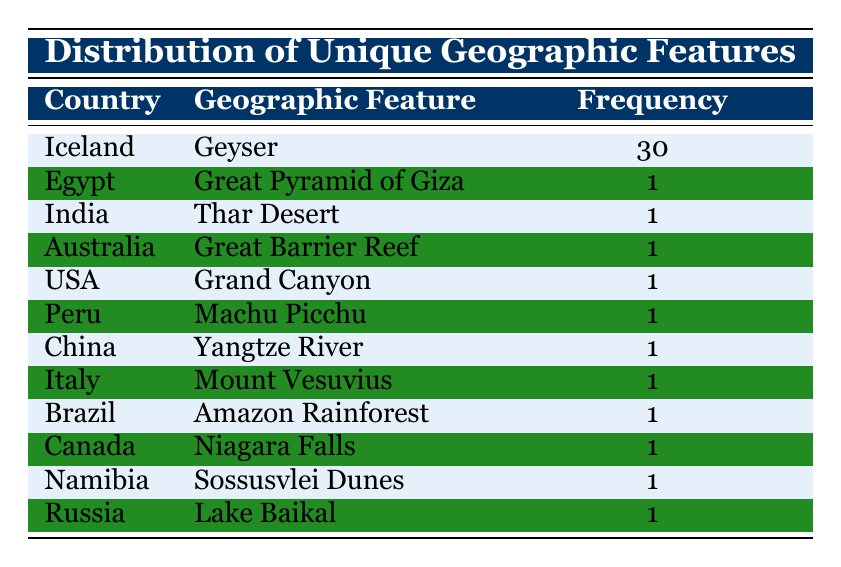What is the unique geographic feature of Iceland? The table indicates that the unique geographic feature of Iceland is a Geyser.
Answer: Geyser How many countries have a frequency of 1 for their geographic features? By counting the rows for countries with a frequency of 1, we find there are 11 such countries: Egypt, India, Australia, USA, Peru, China, Italy, Brazil, Canada, Namibia, and Russia.
Answer: 11 Which country has the highest frequency of a geographic feature? The table shows that Iceland has the highest frequency of 30 for its Geyser, making it the country with the most unique geographic feature frequency.
Answer: Iceland What is the total frequency of all the listed geographic features? To find the total frequency, we sum all the frequencies: 30 (Iceland) + 1 (Egypt) + 1 + 1 + 1 + 1 + 1 + 1 + 1 + 1 + 1 (for the 10 other countries) equals 41.
Answer: 41 Is the Amazon Rainforest a unique feature found in Brazil? Yes, according to the table, the Amazon Rainforest is listed as a unique geographic feature of Brazil with a frequency of 1.
Answer: Yes What is the frequency difference between the Geyser in Iceland and the Great Pyramid of Giza in Egypt? The frequency of the Geyser in Iceland is 30, while the frequency of the Great Pyramid of Giza in Egypt is 1. The difference is 30 - 1 = 29.
Answer: 29 Which geographic feature appears in the most countries? The table indicates that the Geyser in Iceland is the only feature appearing across multiple instances, suggesting it dominates in frequency. Other features only appear once in their respective countries.
Answer: Geyser Which two countries have geographic features related to natural wonders and how frequently are they listed? The table features Canada with Niagara Falls and Australia with the Great Barrier Reef, both with a frequency of 1.
Answer: Canada and Australia; frequency 1 each How many geographic features are associated with a unique frequency greater than 1? The only geographic feature listed in the table with a frequency greater than 1 is the Geyser in Iceland with a frequency of 30, implying only one feature surpasses the count of 1.
Answer: 1 